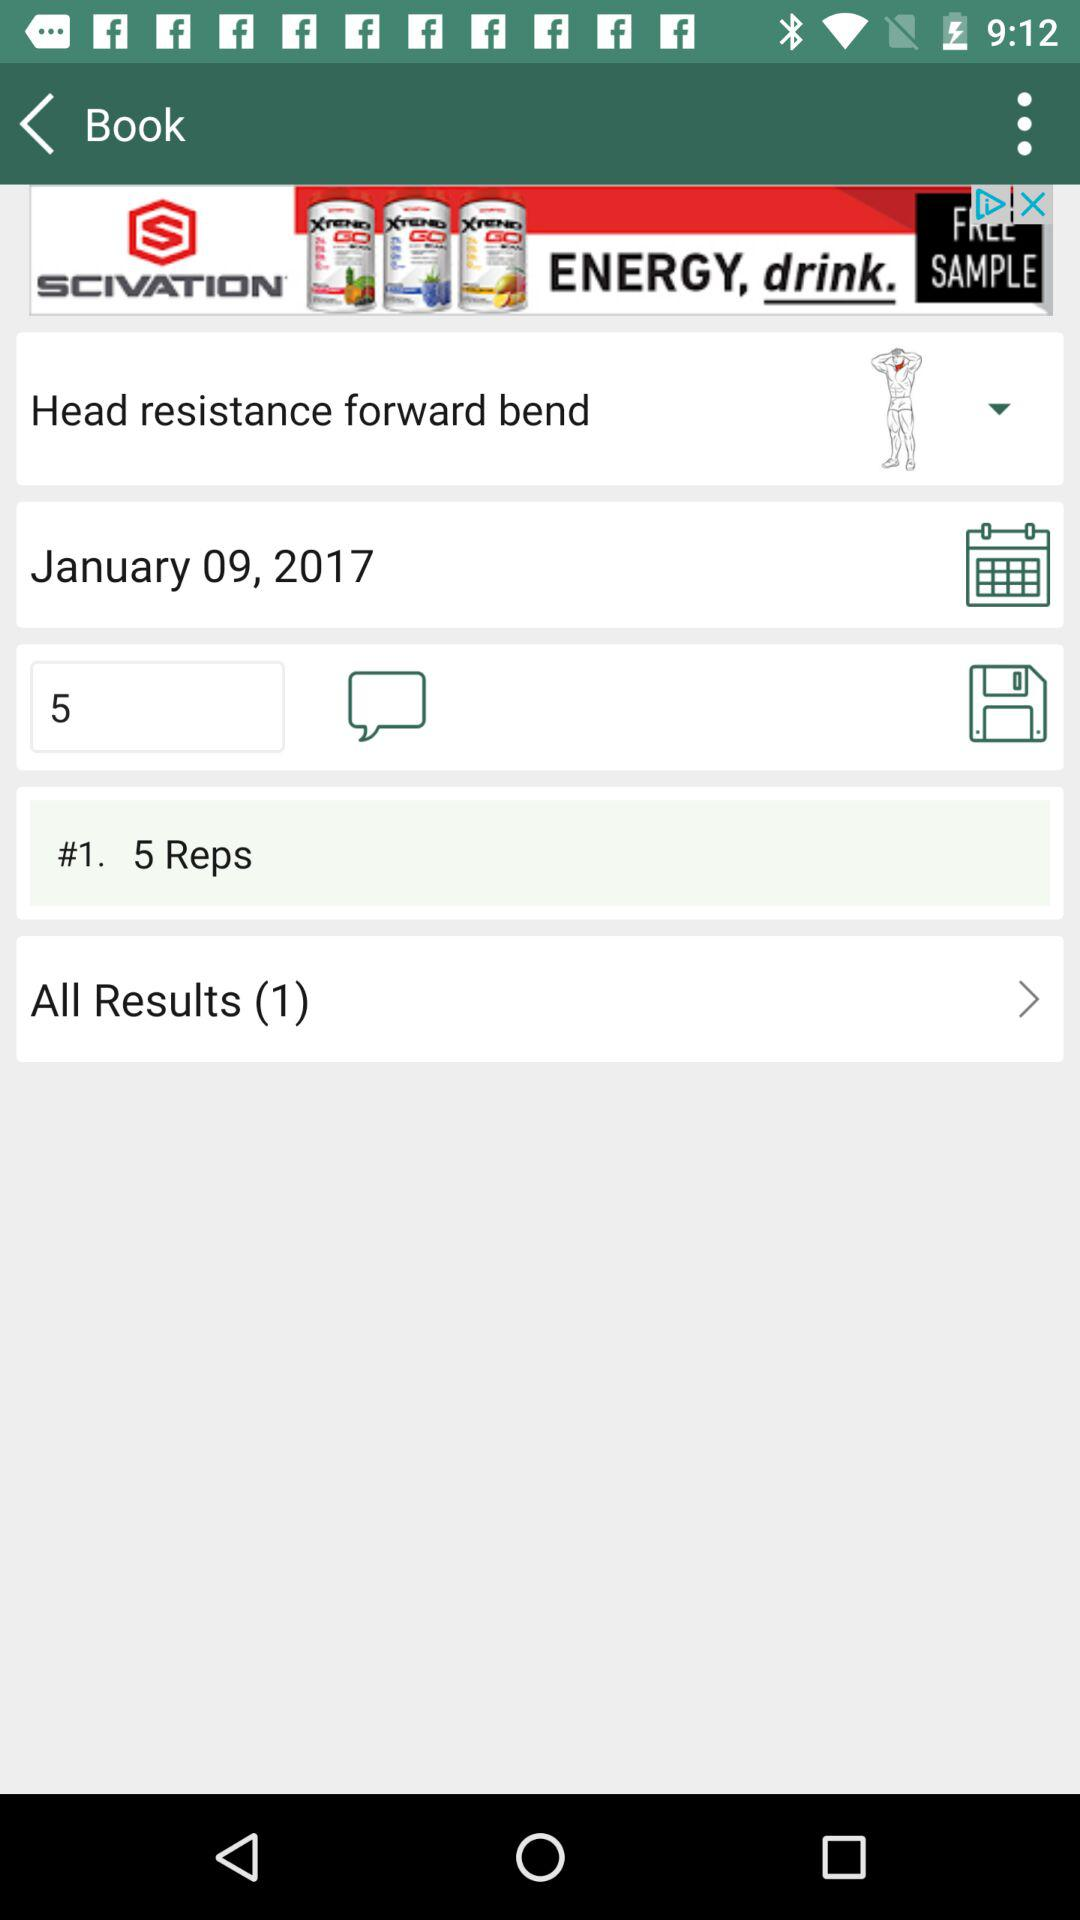How many results in total are there? There is 1 result in total. 